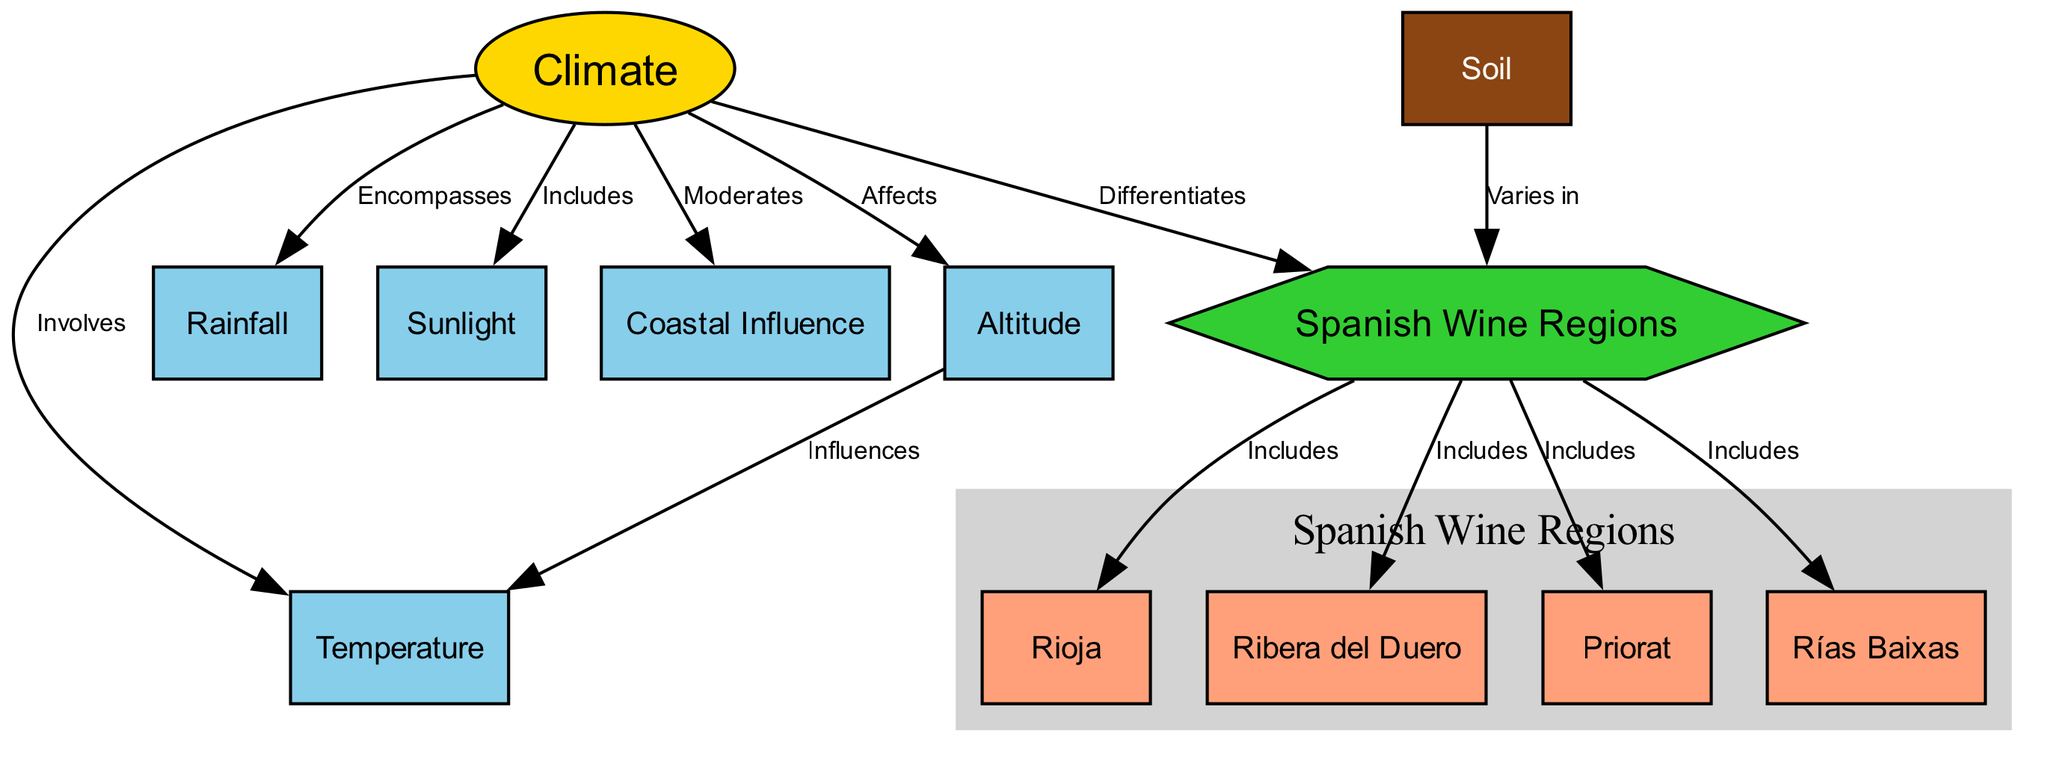What is the main factor that influences the Spanish wine regions? In the diagram, "Climate" is depicted as a central node connected to various components influencing it and impacted by it, thus it stands as the main factor.
Answer: Climate How many Spanish wine regions are included in the diagram? The diagram lists four specific Spanish wine regions: Rioja, Ribera del Duero, Priorat, and Rías Baixas, indicating there are four regions in total.
Answer: 4 What role does altitude play in relation to temperature? The diagram shows a directed edge from "Altitude" to "Temperature" labeled "Influences", indicating that altitude has a direct impact on temperature.
Answer: Influences Which Spanish wine region is noted for its high altitude vineyards? "Ribera del Duero" is directly described in the diagram as noted for its high altitude vineyards, answering the question about which region it refers to.
Answer: Ribera del Duero What aspect of climate affects vine growth? The diagram clearly indicates that "Rainfall" is an essential aspect that affects irrigation, which in turn influences vine growth as illustrated in the connection.
Answer: Rainfall How does coastal influence contribute to the climate in Spanish wine regions? The diagram specifies that "Coastal Influence" moderates temperature and humidity levels, which in turn affects the local climate and conditions in the regions.
Answer: Moderates What type of soil is linked to the Spanish wine regions? The diagram connects "Soil" to "Spanish Wine Regions," indicating that the type of soil varies across different regions, impacting their characteristics.
Answer: Varies in What is produced in the Priorat region known for? The diagram describes "Priorat" as known for steep terrains and slate soils, which produce intensely flavored wines, thus directly stating its significance.
Answer: Intensely flavored wines What climate condition is essential for grape maturity? According to the diagram, "Sunlight" is specifically mentioned as essential for photosynthesis, leading to the maturation of grapes in Spanish wine regions.
Answer: Sunlight 